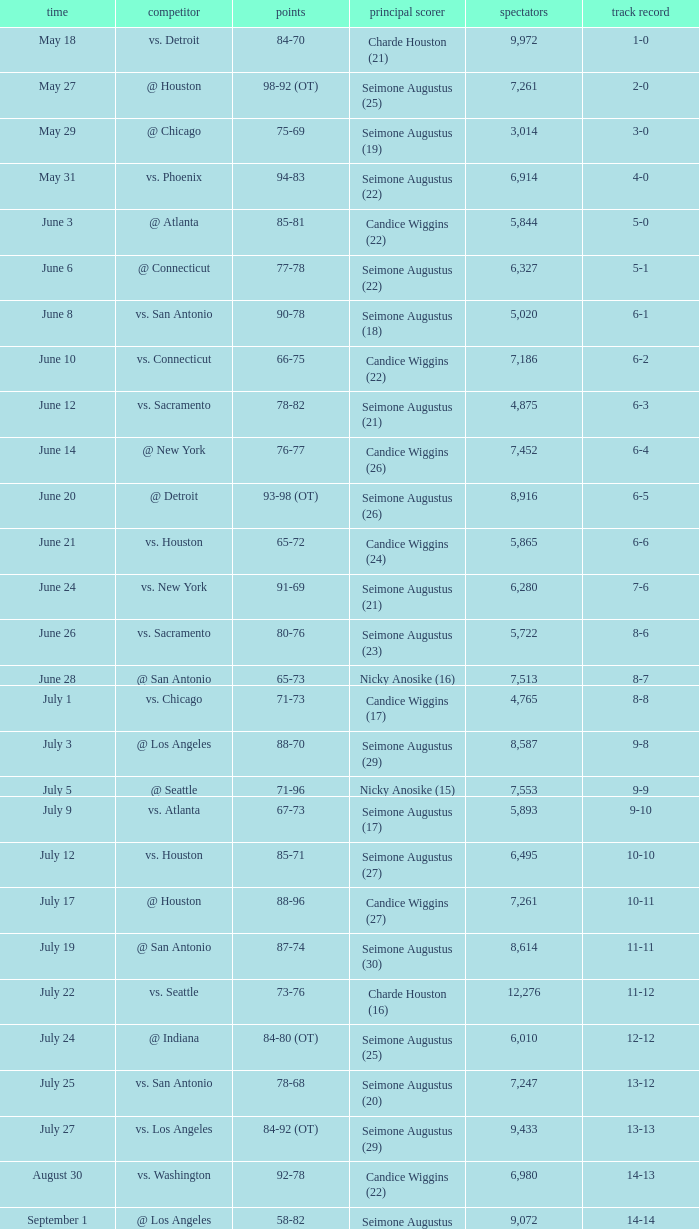Which Leading Scorer has an Opponent of @ seattle, and a Record of 14-16? Seimone Augustus (26). Could you parse the entire table? {'header': ['time', 'competitor', 'points', 'principal scorer', 'spectators', 'track record'], 'rows': [['May 18', 'vs. Detroit', '84-70', 'Charde Houston (21)', '9,972', '1-0'], ['May 27', '@ Houston', '98-92 (OT)', 'Seimone Augustus (25)', '7,261', '2-0'], ['May 29', '@ Chicago', '75-69', 'Seimone Augustus (19)', '3,014', '3-0'], ['May 31', 'vs. Phoenix', '94-83', 'Seimone Augustus (22)', '6,914', '4-0'], ['June 3', '@ Atlanta', '85-81', 'Candice Wiggins (22)', '5,844', '5-0'], ['June 6', '@ Connecticut', '77-78', 'Seimone Augustus (22)', '6,327', '5-1'], ['June 8', 'vs. San Antonio', '90-78', 'Seimone Augustus (18)', '5,020', '6-1'], ['June 10', 'vs. Connecticut', '66-75', 'Candice Wiggins (22)', '7,186', '6-2'], ['June 12', 'vs. Sacramento', '78-82', 'Seimone Augustus (21)', '4,875', '6-3'], ['June 14', '@ New York', '76-77', 'Candice Wiggins (26)', '7,452', '6-4'], ['June 20', '@ Detroit', '93-98 (OT)', 'Seimone Augustus (26)', '8,916', '6-5'], ['June 21', 'vs. Houston', '65-72', 'Candice Wiggins (24)', '5,865', '6-6'], ['June 24', 'vs. New York', '91-69', 'Seimone Augustus (21)', '6,280', '7-6'], ['June 26', 'vs. Sacramento', '80-76', 'Seimone Augustus (23)', '5,722', '8-6'], ['June 28', '@ San Antonio', '65-73', 'Nicky Anosike (16)', '7,513', '8-7'], ['July 1', 'vs. Chicago', '71-73', 'Candice Wiggins (17)', '4,765', '8-8'], ['July 3', '@ Los Angeles', '88-70', 'Seimone Augustus (29)', '8,587', '9-8'], ['July 5', '@ Seattle', '71-96', 'Nicky Anosike (15)', '7,553', '9-9'], ['July 9', 'vs. Atlanta', '67-73', 'Seimone Augustus (17)', '5,893', '9-10'], ['July 12', 'vs. Houston', '85-71', 'Seimone Augustus (27)', '6,495', '10-10'], ['July 17', '@ Houston', '88-96', 'Candice Wiggins (27)', '7,261', '10-11'], ['July 19', '@ San Antonio', '87-74', 'Seimone Augustus (30)', '8,614', '11-11'], ['July 22', 'vs. Seattle', '73-76', 'Charde Houston (16)', '12,276', '11-12'], ['July 24', '@ Indiana', '84-80 (OT)', 'Seimone Augustus (25)', '6,010', '12-12'], ['July 25', 'vs. San Antonio', '78-68', 'Seimone Augustus (20)', '7,247', '13-12'], ['July 27', 'vs. Los Angeles', '84-92 (OT)', 'Seimone Augustus (29)', '9,433', '13-13'], ['August 30', 'vs. Washington', '92-78', 'Candice Wiggins (22)', '6,980', '14-13'], ['September 1', '@ Los Angeles', '58-82', 'Seimone Augustus (13)', '9,072', '14-14'], ['September 3', '@ Phoenix', '96-103', 'Seimone Augustus (27)', '7,722', '14-15'], ['September 6', '@ Seattle', '88-96', 'Seimone Augustus (26)', '9,339', '14-16'], ['September 7', '@ Sacramento', '71-78', 'Charde Houston (19)', '7,999', '14-17'], ['September 9', 'vs. Indiana', '86-76', 'Charde Houston (18)', '6,706', '15-17'], ['September 12', 'vs. Phoenix', '87-96', 'Lindsey Harding (20)', '8,343', '15-18'], ['September 14', '@ Washington', '96-70', 'Charde Houston (18)', '10,438', '16-18']]} 